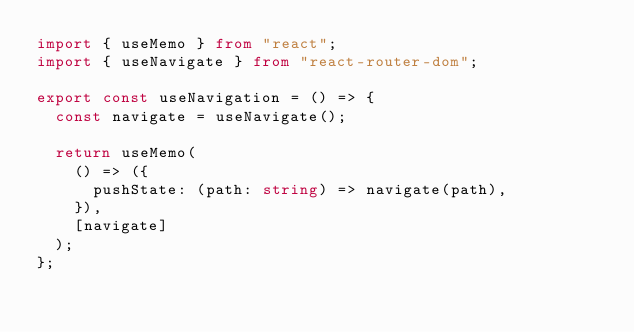<code> <loc_0><loc_0><loc_500><loc_500><_TypeScript_>import { useMemo } from "react";
import { useNavigate } from "react-router-dom";

export const useNavigation = () => {
  const navigate = useNavigate();

  return useMemo(
    () => ({
      pushState: (path: string) => navigate(path),
    }),
    [navigate]
  );
};
</code> 